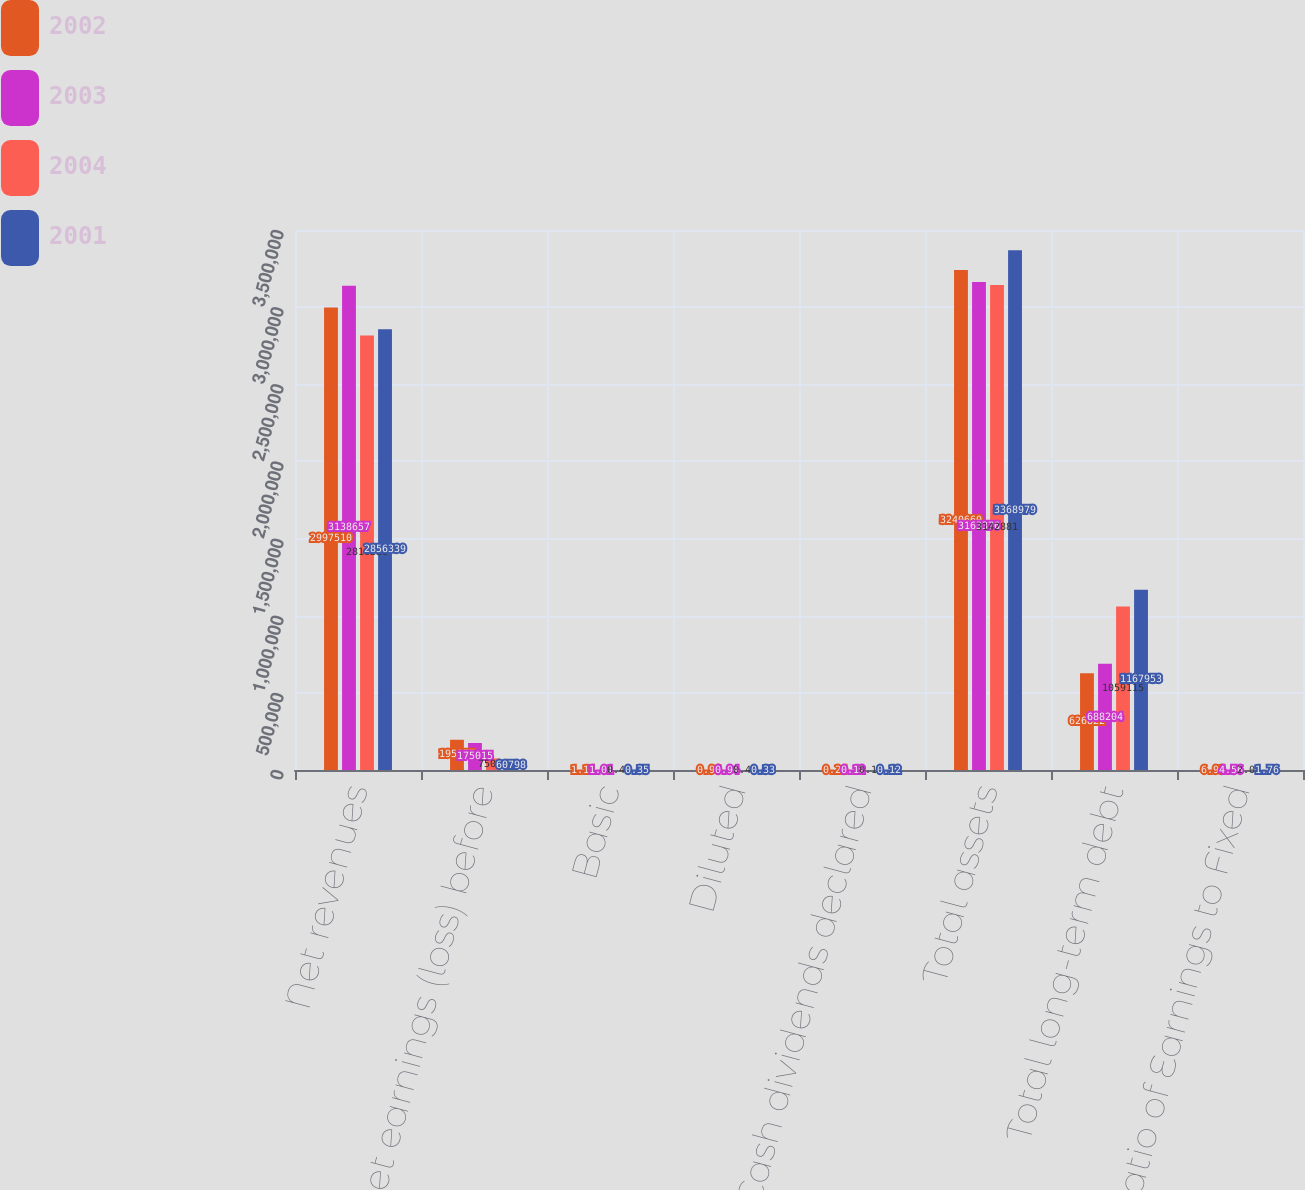Convert chart. <chart><loc_0><loc_0><loc_500><loc_500><stacked_bar_chart><ecel><fcel>Net revenues<fcel>Net earnings (loss) before<fcel>Basic<fcel>Diluted<fcel>Cash dividends declared<fcel>Total assets<fcel>Total long-term debt<fcel>Ratio of Earnings to Fixed<nl><fcel>2002<fcel>2.99751e+06<fcel>195977<fcel>1.11<fcel>0.96<fcel>0.24<fcel>3.24066e+06<fcel>626822<fcel>6.93<nl><fcel>2003<fcel>3.13866e+06<fcel>175015<fcel>1.01<fcel>0.94<fcel>0.12<fcel>3.16338e+06<fcel>688204<fcel>4.56<nl><fcel>2004<fcel>2.81623e+06<fcel>75058<fcel>0.43<fcel>0.43<fcel>0.12<fcel>3.14288e+06<fcel>1.05912e+06<fcel>2.05<nl><fcel>2001<fcel>2.85634e+06<fcel>60798<fcel>0.35<fcel>0.33<fcel>0.12<fcel>3.36898e+06<fcel>1.16795e+06<fcel>1.76<nl></chart> 